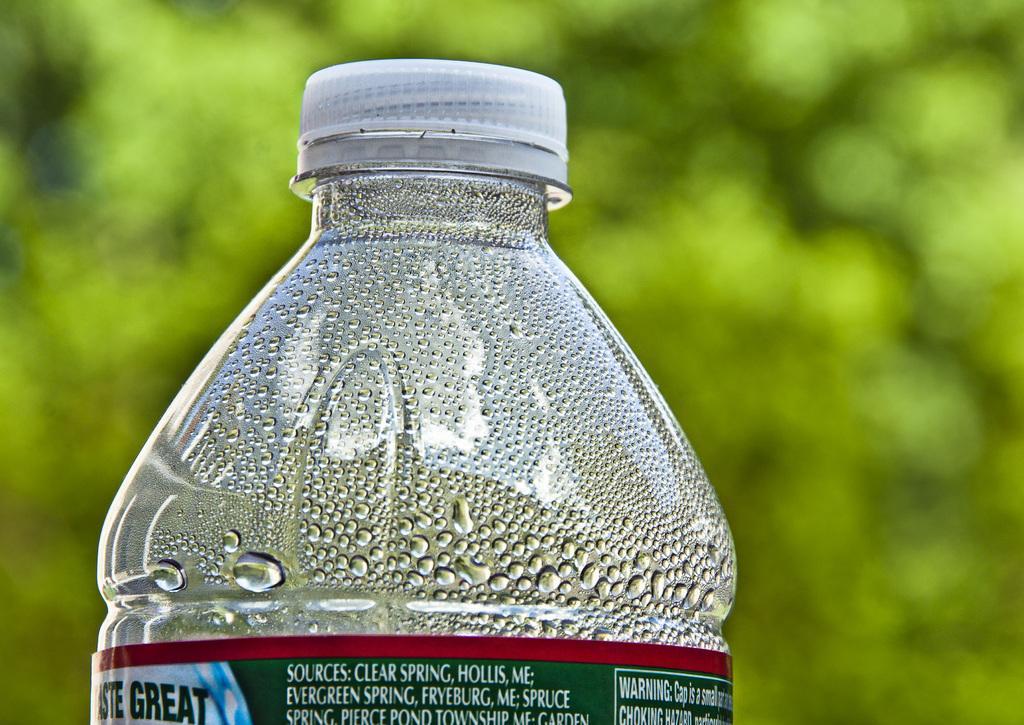In one or two sentences, can you explain what this image depicts? In this image there is a bottle with red and green label and white cap, there are water drops on the bottle. 